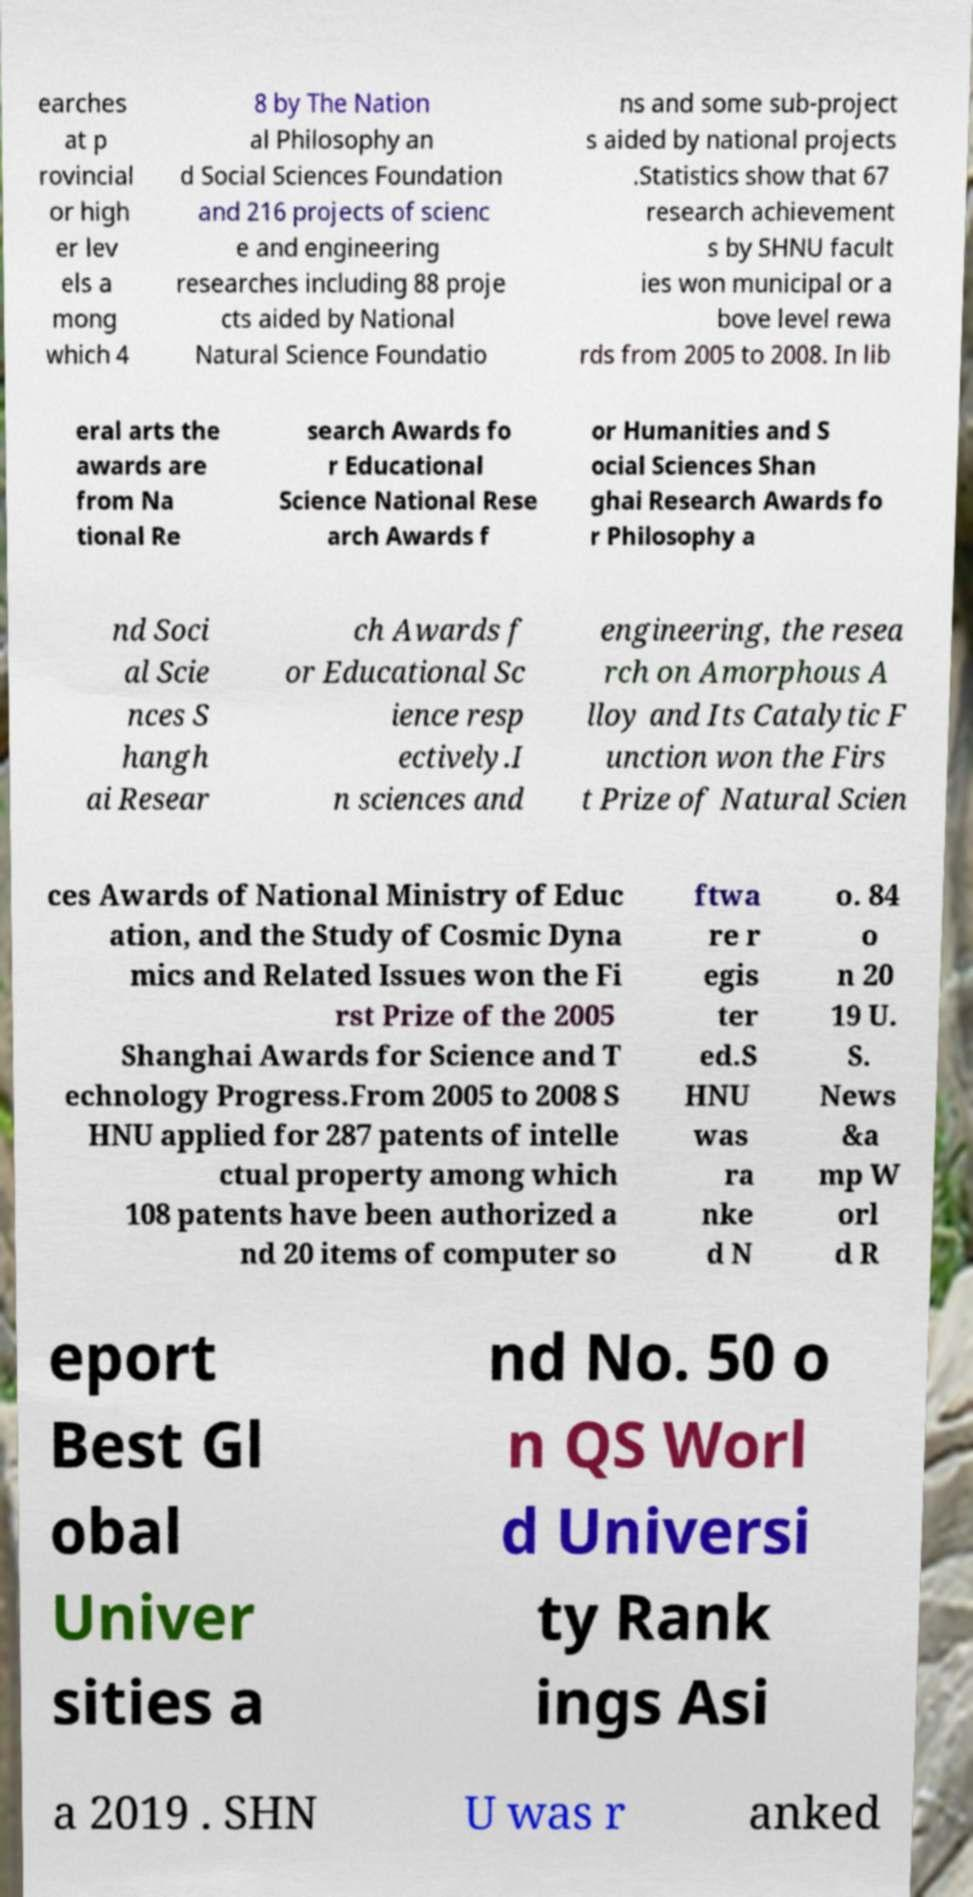Could you assist in decoding the text presented in this image and type it out clearly? earches at p rovincial or high er lev els a mong which 4 8 by The Nation al Philosophy an d Social Sciences Foundation and 216 projects of scienc e and engineering researches including 88 proje cts aided by National Natural Science Foundatio ns and some sub-project s aided by national projects .Statistics show that 67 research achievement s by SHNU facult ies won municipal or a bove level rewa rds from 2005 to 2008. In lib eral arts the awards are from Na tional Re search Awards fo r Educational Science National Rese arch Awards f or Humanities and S ocial Sciences Shan ghai Research Awards fo r Philosophy a nd Soci al Scie nces S hangh ai Resear ch Awards f or Educational Sc ience resp ectively.I n sciences and engineering, the resea rch on Amorphous A lloy and Its Catalytic F unction won the Firs t Prize of Natural Scien ces Awards of National Ministry of Educ ation, and the Study of Cosmic Dyna mics and Related Issues won the Fi rst Prize of the 2005 Shanghai Awards for Science and T echnology Progress.From 2005 to 2008 S HNU applied for 287 patents of intelle ctual property among which 108 patents have been authorized a nd 20 items of computer so ftwa re r egis ter ed.S HNU was ra nke d N o. 84 o n 20 19 U. S. News &a mp W orl d R eport Best Gl obal Univer sities a nd No. 50 o n QS Worl d Universi ty Rank ings Asi a 2019 . SHN U was r anked 